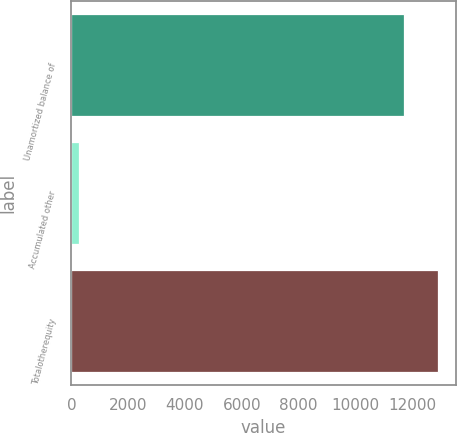<chart> <loc_0><loc_0><loc_500><loc_500><bar_chart><fcel>Unamortized balance of<fcel>Accumulated other<fcel>Totalotherequity<nl><fcel>11700<fcel>281<fcel>12893.6<nl></chart> 